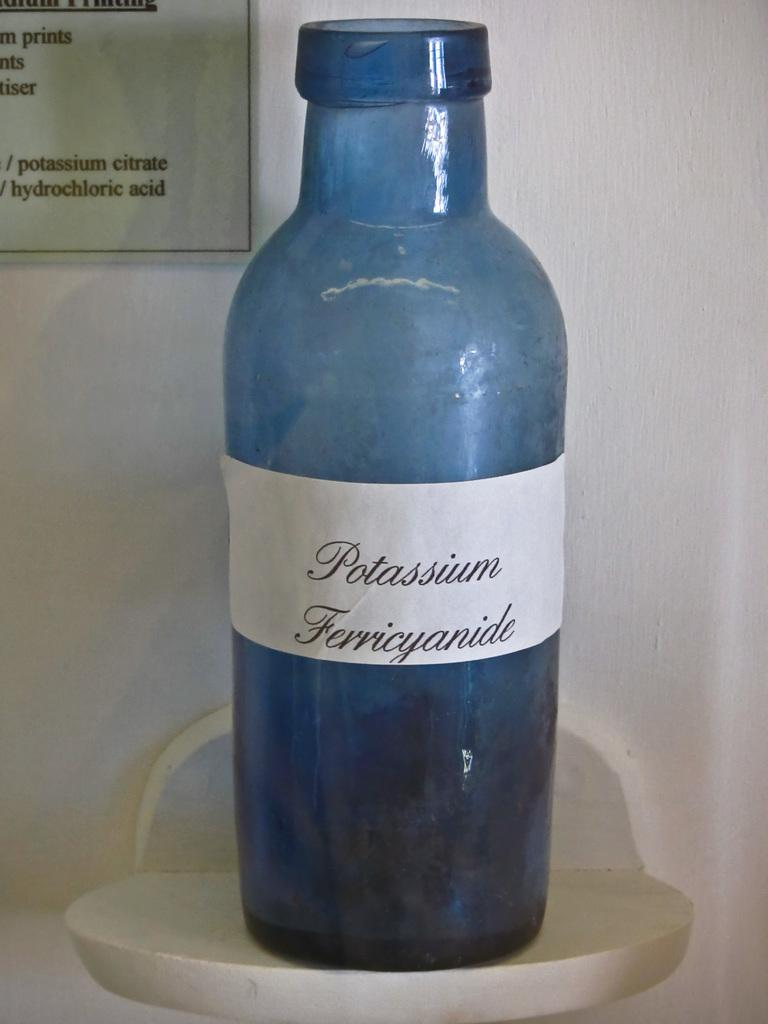<image>
Relay a brief, clear account of the picture shown. A blue bottle of Potassium Ferricyanide sits on a small perch. 